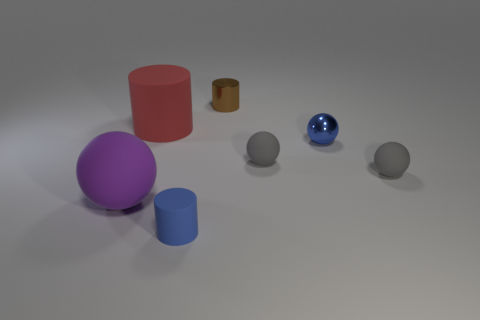Is the number of small rubber spheres less than the number of large brown shiny cubes?
Make the answer very short. No. There is a small thing in front of the purple ball; does it have the same color as the tiny shiny sphere?
Your answer should be very brief. Yes. What material is the tiny blue object behind the big rubber object that is on the left side of the big cylinder that is in front of the tiny metallic cylinder?
Ensure brevity in your answer.  Metal. Is there a matte ball of the same color as the small shiny sphere?
Offer a terse response. No. Is the number of gray balls that are to the right of the purple matte ball less than the number of red cylinders?
Provide a succinct answer. No. Does the object that is in front of the purple matte thing have the same size as the shiny cylinder?
Offer a terse response. Yes. How many blue things are both to the right of the brown cylinder and in front of the tiny blue metal thing?
Your answer should be compact. 0. There is a blue object that is behind the object that is left of the big red rubber cylinder; what size is it?
Ensure brevity in your answer.  Small. Is the number of small metal cylinders that are on the left side of the metallic cylinder less than the number of big matte objects on the right side of the large purple rubber sphere?
Your response must be concise. Yes. Is the color of the large thing that is behind the tiny blue metallic thing the same as the large rubber thing that is to the left of the large rubber cylinder?
Give a very brief answer. No. 